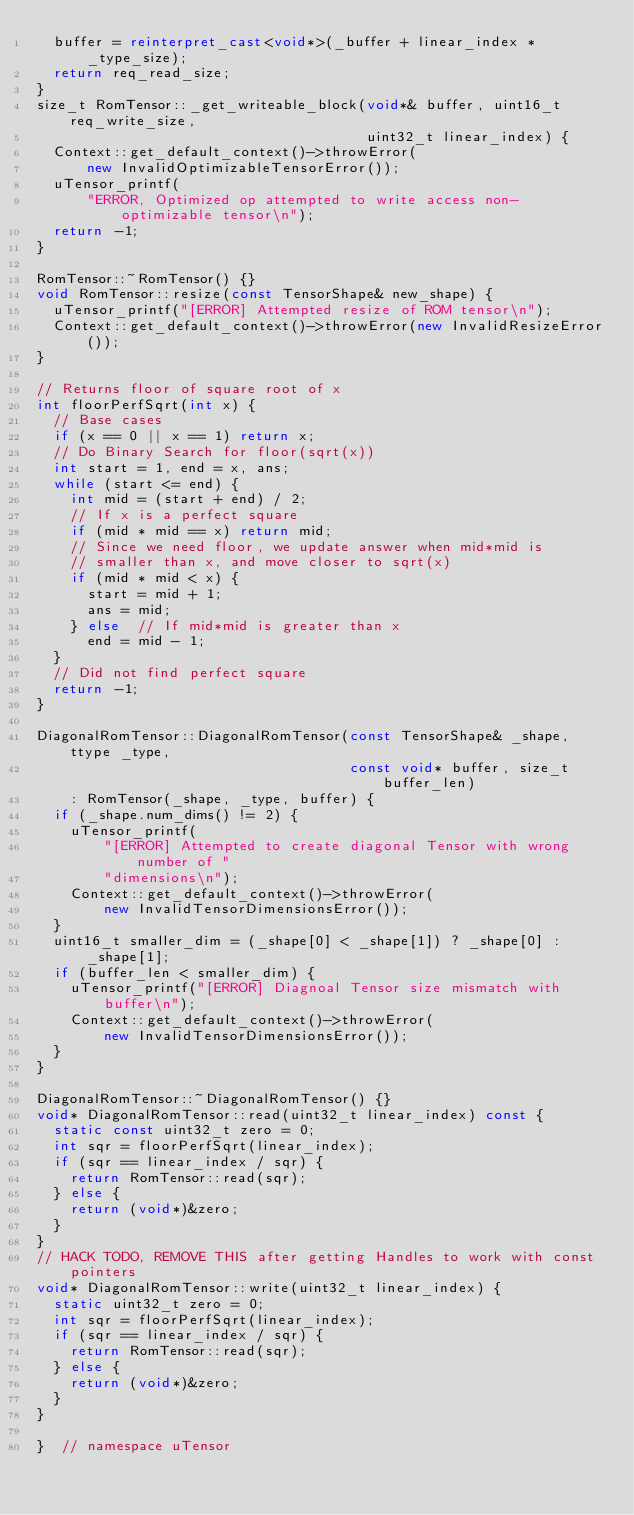<code> <loc_0><loc_0><loc_500><loc_500><_C++_>  buffer = reinterpret_cast<void*>(_buffer + linear_index * _type_size);
  return req_read_size;
}
size_t RomTensor::_get_writeable_block(void*& buffer, uint16_t req_write_size,
                                       uint32_t linear_index) {
  Context::get_default_context()->throwError(
      new InvalidOptimizableTensorError());
  uTensor_printf(
      "ERROR, Optimized op attempted to write access non-optimizable tensor\n");
  return -1;
}

RomTensor::~RomTensor() {}
void RomTensor::resize(const TensorShape& new_shape) {
  uTensor_printf("[ERROR] Attempted resize of ROM tensor\n");
  Context::get_default_context()->throwError(new InvalidResizeError());
}

// Returns floor of square root of x
int floorPerfSqrt(int x) {
  // Base cases
  if (x == 0 || x == 1) return x;
  // Do Binary Search for floor(sqrt(x))
  int start = 1, end = x, ans;
  while (start <= end) {
    int mid = (start + end) / 2;
    // If x is a perfect square
    if (mid * mid == x) return mid;
    // Since we need floor, we update answer when mid*mid is
    // smaller than x, and move closer to sqrt(x)
    if (mid * mid < x) {
      start = mid + 1;
      ans = mid;
    } else  // If mid*mid is greater than x
      end = mid - 1;
  }
  // Did not find perfect square
  return -1;
}

DiagonalRomTensor::DiagonalRomTensor(const TensorShape& _shape, ttype _type,
                                     const void* buffer, size_t buffer_len)
    : RomTensor(_shape, _type, buffer) {
  if (_shape.num_dims() != 2) {
    uTensor_printf(
        "[ERROR] Attempted to create diagonal Tensor with wrong number of "
        "dimensions\n");
    Context::get_default_context()->throwError(
        new InvalidTensorDimensionsError());
  }
  uint16_t smaller_dim = (_shape[0] < _shape[1]) ? _shape[0] : _shape[1];
  if (buffer_len < smaller_dim) {
    uTensor_printf("[ERROR] Diagnoal Tensor size mismatch with buffer\n");
    Context::get_default_context()->throwError(
        new InvalidTensorDimensionsError());
  }
}

DiagonalRomTensor::~DiagonalRomTensor() {}
void* DiagonalRomTensor::read(uint32_t linear_index) const {
  static const uint32_t zero = 0;
  int sqr = floorPerfSqrt(linear_index);
  if (sqr == linear_index / sqr) {
    return RomTensor::read(sqr);
  } else {
    return (void*)&zero;
  }
}
// HACK TODO, REMOVE THIS after getting Handles to work with const pointers
void* DiagonalRomTensor::write(uint32_t linear_index) {
  static uint32_t zero = 0;
  int sqr = floorPerfSqrt(linear_index);
  if (sqr == linear_index / sqr) {
    return RomTensor::read(sqr);
  } else {
    return (void*)&zero;
  }
}

}  // namespace uTensor
</code> 